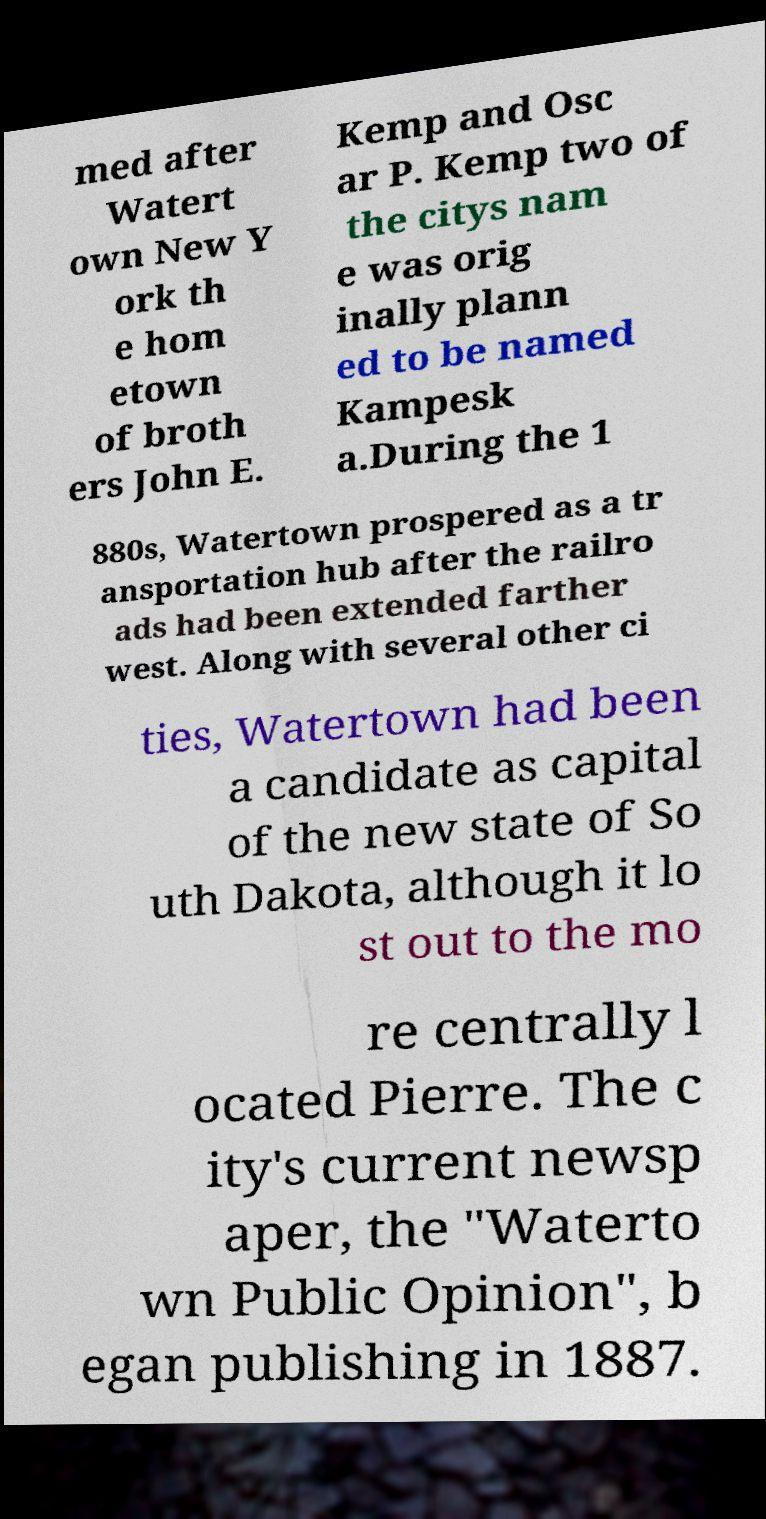Please read and relay the text visible in this image. What does it say? med after Watert own New Y ork th e hom etown of broth ers John E. Kemp and Osc ar P. Kemp two of the citys nam e was orig inally plann ed to be named Kampesk a.During the 1 880s, Watertown prospered as a tr ansportation hub after the railro ads had been extended farther west. Along with several other ci ties, Watertown had been a candidate as capital of the new state of So uth Dakota, although it lo st out to the mo re centrally l ocated Pierre. The c ity's current newsp aper, the "Waterto wn Public Opinion", b egan publishing in 1887. 